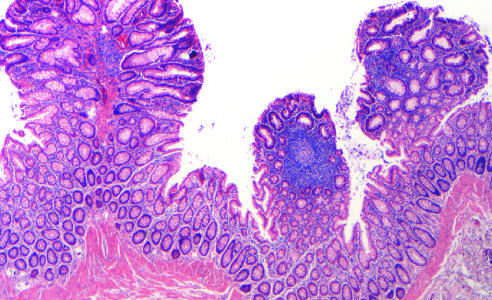how many tubular adenomas are present in this single microscopic field?
Answer the question using a single word or phrase. Three 